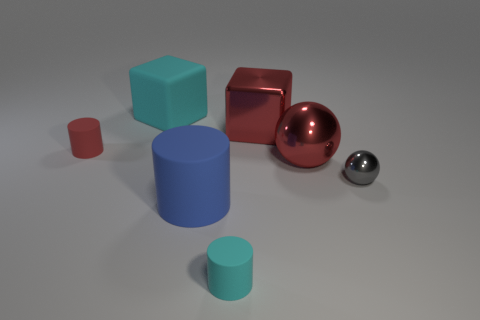Add 1 red metal spheres. How many objects exist? 8 Subtract 2 cylinders. How many cylinders are left? 1 Subtract all tiny cyan rubber cylinders. How many cylinders are left? 2 Subtract all cubes. How many objects are left? 5 Subtract all purple cubes. How many brown balls are left? 0 Subtract all red cubes. Subtract all small metallic objects. How many objects are left? 5 Add 5 small shiny balls. How many small shiny balls are left? 6 Add 7 small purple cylinders. How many small purple cylinders exist? 7 Subtract all cyan cylinders. How many cylinders are left? 2 Subtract 1 red blocks. How many objects are left? 6 